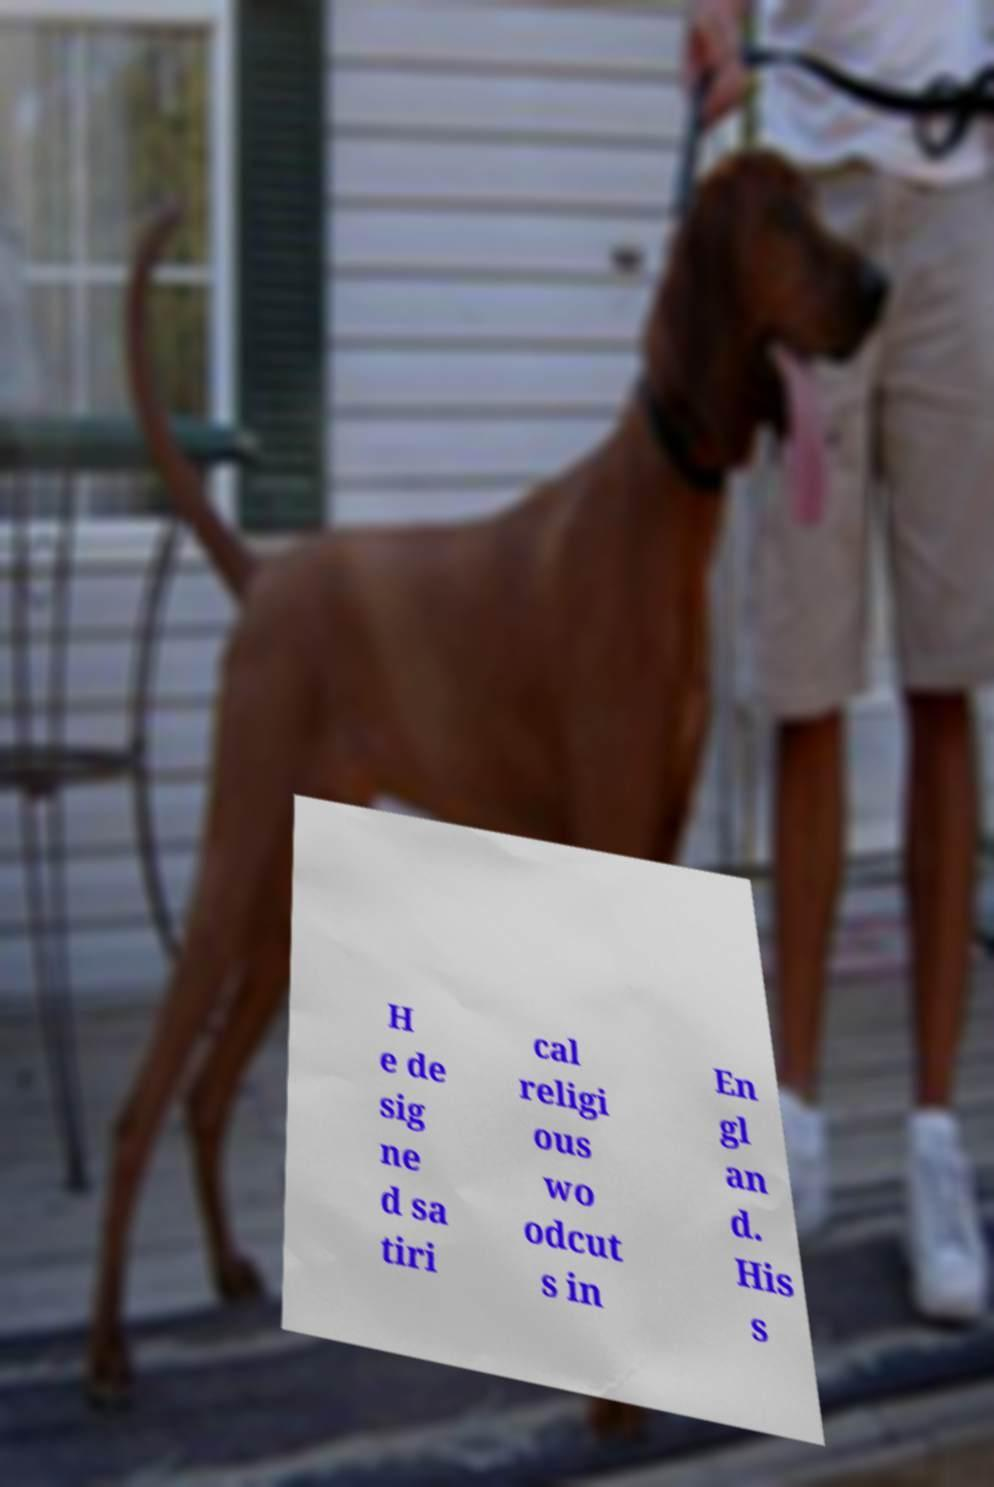Could you extract and type out the text from this image? H e de sig ne d sa tiri cal religi ous wo odcut s in En gl an d. His s 